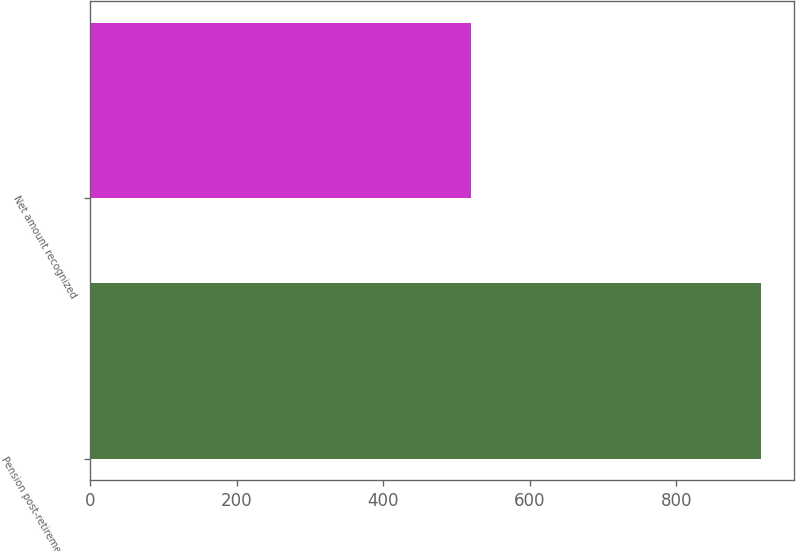<chart> <loc_0><loc_0><loc_500><loc_500><bar_chart><fcel>Pension post-retirement and<fcel>Net amount recognized<nl><fcel>915<fcel>520<nl></chart> 